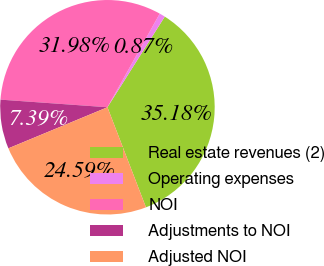Convert chart. <chart><loc_0><loc_0><loc_500><loc_500><pie_chart><fcel>Real estate revenues (2)<fcel>Operating expenses<fcel>NOI<fcel>Adjustments to NOI<fcel>Adjusted NOI<nl><fcel>35.18%<fcel>0.87%<fcel>31.98%<fcel>7.39%<fcel>24.59%<nl></chart> 